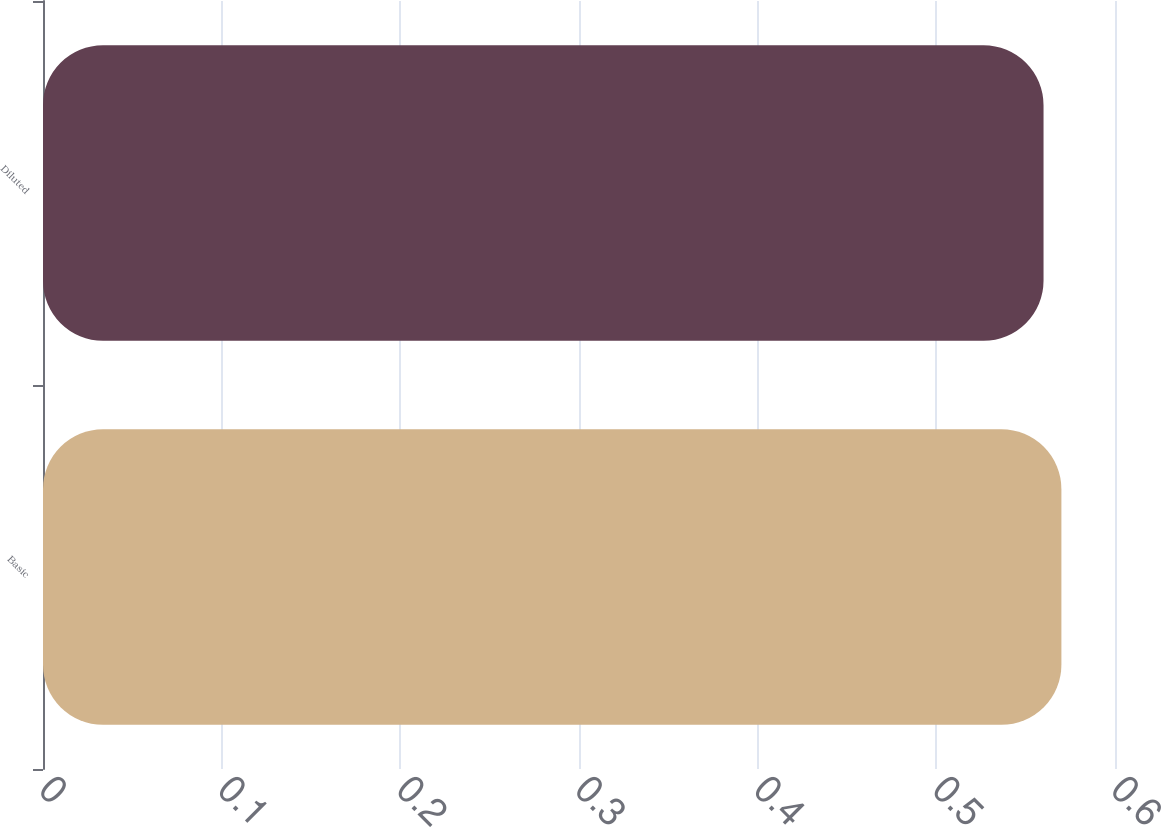Convert chart. <chart><loc_0><loc_0><loc_500><loc_500><bar_chart><fcel>Basic<fcel>Diluted<nl><fcel>0.57<fcel>0.56<nl></chart> 